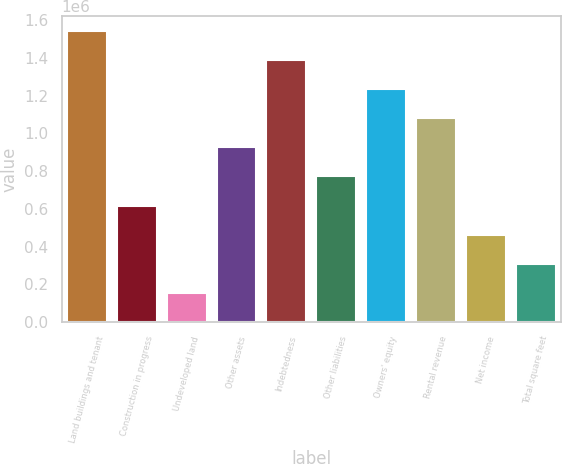Convert chart to OTSL. <chart><loc_0><loc_0><loc_500><loc_500><bar_chart><fcel>Land buildings and tenant<fcel>Construction in progress<fcel>Undeveloped land<fcel>Other assets<fcel>Indebtedness<fcel>Other liabilities<fcel>Owners' equity<fcel>Rental revenue<fcel>Net income<fcel>Total square feet<nl><fcel>1.54347e+06<fcel>617442<fcel>154430<fcel>926117<fcel>1.38913e+06<fcel>771780<fcel>1.23479e+06<fcel>1.08045e+06<fcel>463105<fcel>308768<nl></chart> 